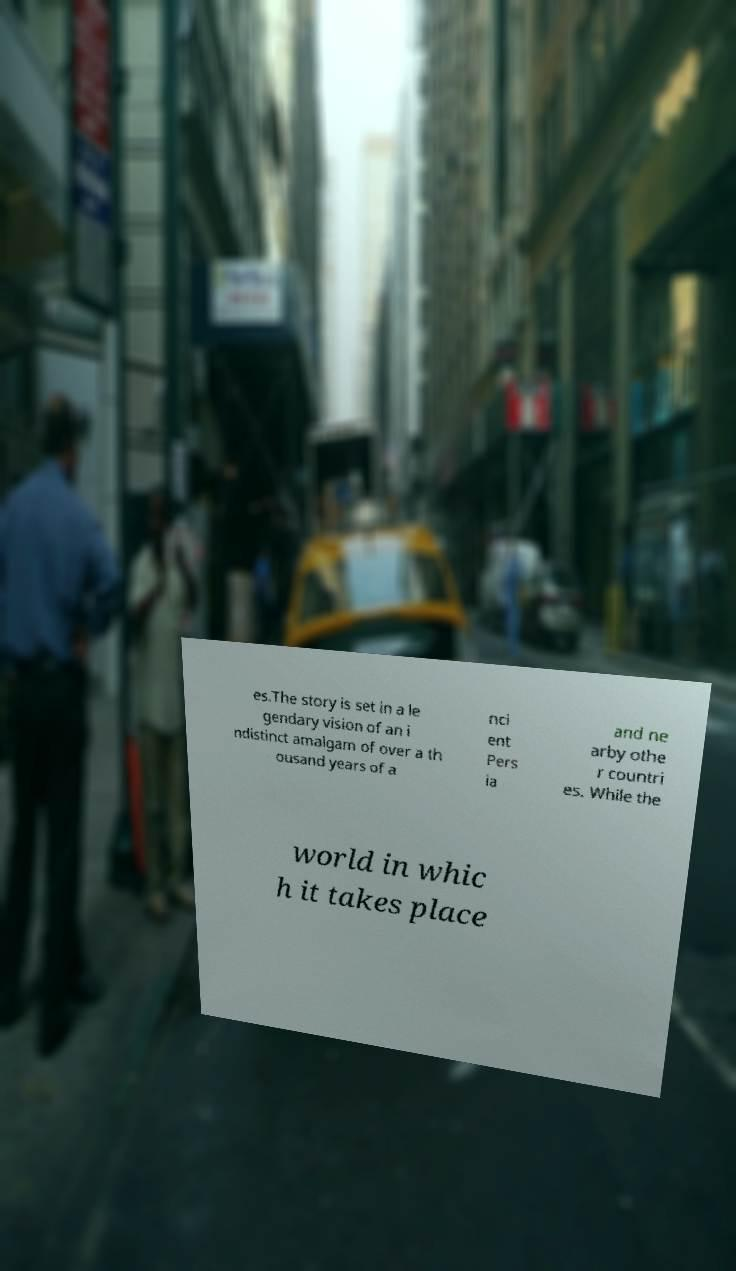What messages or text are displayed in this image? I need them in a readable, typed format. es.The story is set in a le gendary vision of an i ndistinct amalgam of over a th ousand years of a nci ent Pers ia and ne arby othe r countri es. While the world in whic h it takes place 